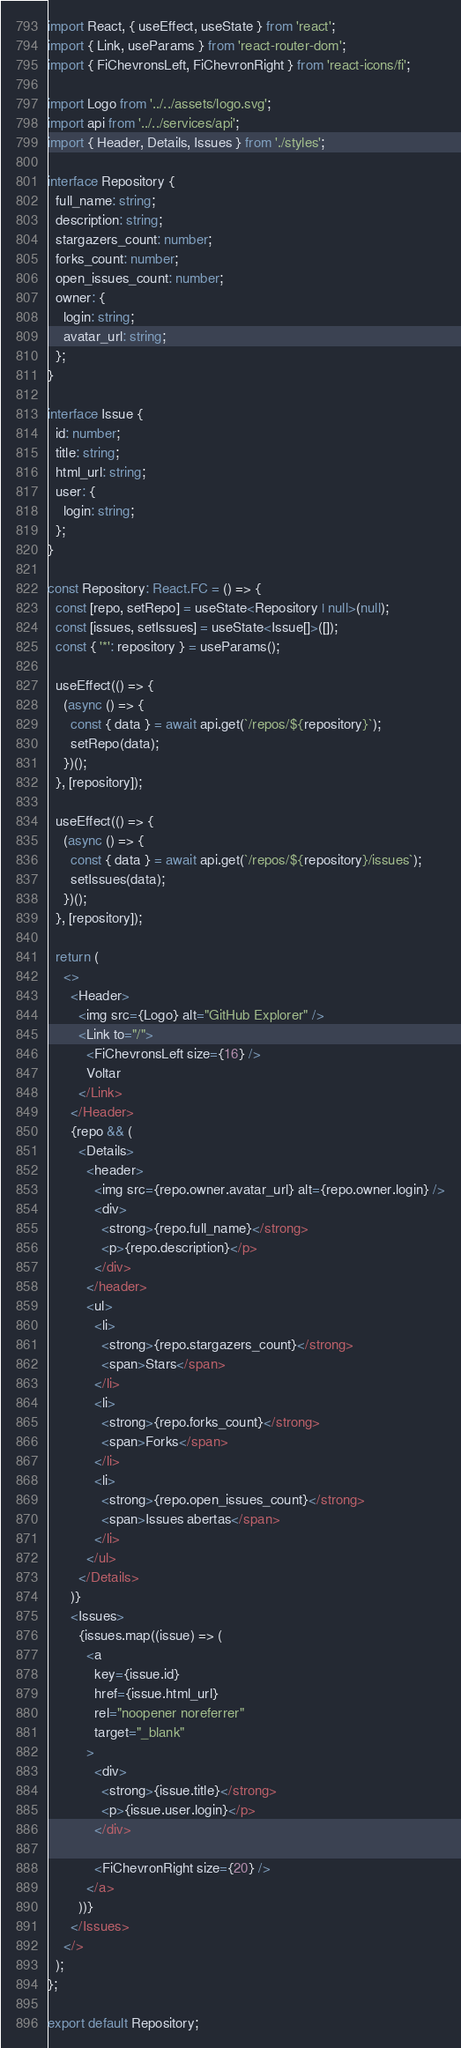<code> <loc_0><loc_0><loc_500><loc_500><_TypeScript_>import React, { useEffect, useState } from 'react';
import { Link, useParams } from 'react-router-dom';
import { FiChevronsLeft, FiChevronRight } from 'react-icons/fi';

import Logo from '../../assets/logo.svg';
import api from '../../services/api';
import { Header, Details, Issues } from './styles';

interface Repository {
  full_name: string;
  description: string;
  stargazers_count: number;
  forks_count: number;
  open_issues_count: number;
  owner: {
    login: string;
    avatar_url: string;
  };
}

interface Issue {
  id: number;
  title: string;
  html_url: string;
  user: {
    login: string;
  };
}

const Repository: React.FC = () => {
  const [repo, setRepo] = useState<Repository | null>(null);
  const [issues, setIssues] = useState<Issue[]>([]);
  const { '*': repository } = useParams();

  useEffect(() => {
    (async () => {
      const { data } = await api.get(`/repos/${repository}`);
      setRepo(data);
    })();
  }, [repository]);

  useEffect(() => {
    (async () => {
      const { data } = await api.get(`/repos/${repository}/issues`);
      setIssues(data);
    })();
  }, [repository]);

  return (
    <>
      <Header>
        <img src={Logo} alt="GitHub Explorer" />
        <Link to="/">
          <FiChevronsLeft size={16} />
          Voltar
        </Link>
      </Header>
      {repo && (
        <Details>
          <header>
            <img src={repo.owner.avatar_url} alt={repo.owner.login} />
            <div>
              <strong>{repo.full_name}</strong>
              <p>{repo.description}</p>
            </div>
          </header>
          <ul>
            <li>
              <strong>{repo.stargazers_count}</strong>
              <span>Stars</span>
            </li>
            <li>
              <strong>{repo.forks_count}</strong>
              <span>Forks</span>
            </li>
            <li>
              <strong>{repo.open_issues_count}</strong>
              <span>Issues abertas</span>
            </li>
          </ul>
        </Details>
      )}
      <Issues>
        {issues.map((issue) => (
          <a
            key={issue.id}
            href={issue.html_url}
            rel="noopener noreferrer"
            target="_blank"
          >
            <div>
              <strong>{issue.title}</strong>
              <p>{issue.user.login}</p>
            </div>

            <FiChevronRight size={20} />
          </a>
        ))}
      </Issues>
    </>
  );
};

export default Repository;
</code> 